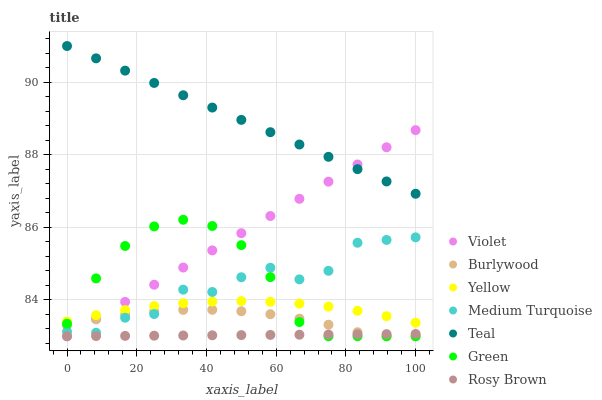Does Rosy Brown have the minimum area under the curve?
Answer yes or no. Yes. Does Teal have the maximum area under the curve?
Answer yes or no. Yes. Does Burlywood have the minimum area under the curve?
Answer yes or no. No. Does Burlywood have the maximum area under the curve?
Answer yes or no. No. Is Violet the smoothest?
Answer yes or no. Yes. Is Medium Turquoise the roughest?
Answer yes or no. Yes. Is Burlywood the smoothest?
Answer yes or no. No. Is Burlywood the roughest?
Answer yes or no. No. Does Burlywood have the lowest value?
Answer yes or no. Yes. Does Yellow have the lowest value?
Answer yes or no. No. Does Teal have the highest value?
Answer yes or no. Yes. Does Burlywood have the highest value?
Answer yes or no. No. Is Rosy Brown less than Medium Turquoise?
Answer yes or no. Yes. Is Medium Turquoise greater than Rosy Brown?
Answer yes or no. Yes. Does Green intersect Violet?
Answer yes or no. Yes. Is Green less than Violet?
Answer yes or no. No. Is Green greater than Violet?
Answer yes or no. No. Does Rosy Brown intersect Medium Turquoise?
Answer yes or no. No. 